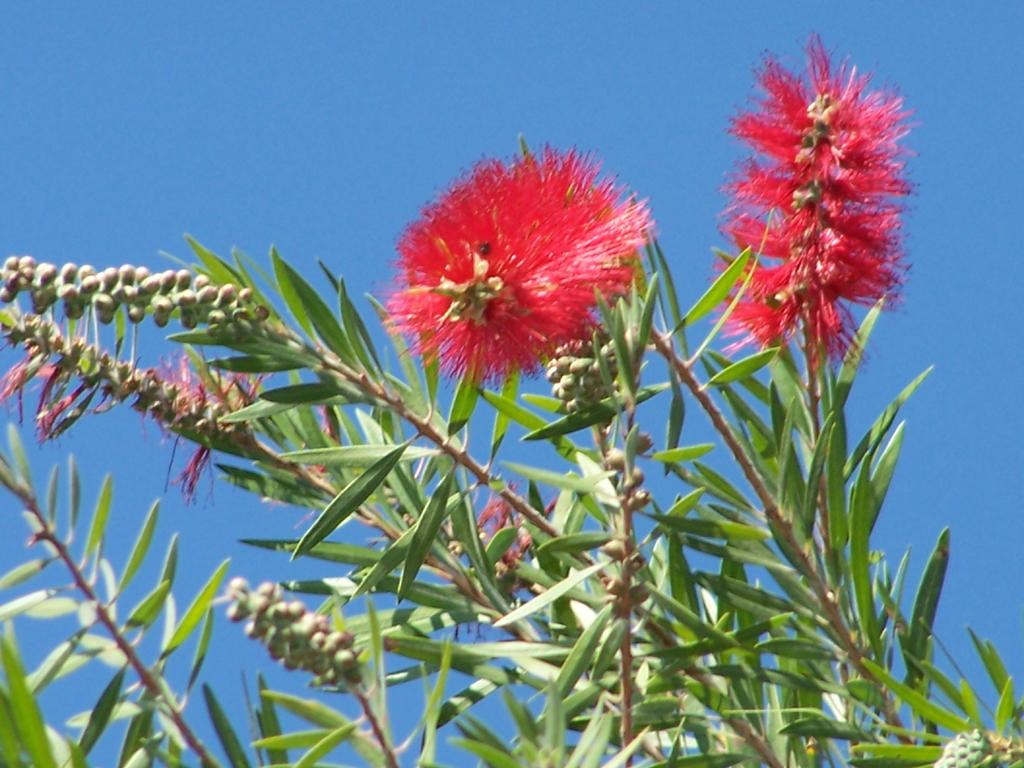What type of living organisms can be seen in the image? There are flowers and buds in the image. What do the flowers and buds belong to? They belong to a plant. What is visible at the top of the image? The sky is visible at the top of the image. Can you tell me how many islands are visible in the image? There are no islands present in the image; it features flowers, buds, and a sky. What grade is the driving instructor giving to the student in the image? There is no driving instructor or student present in the image; it features flowers, buds, and a sky. 